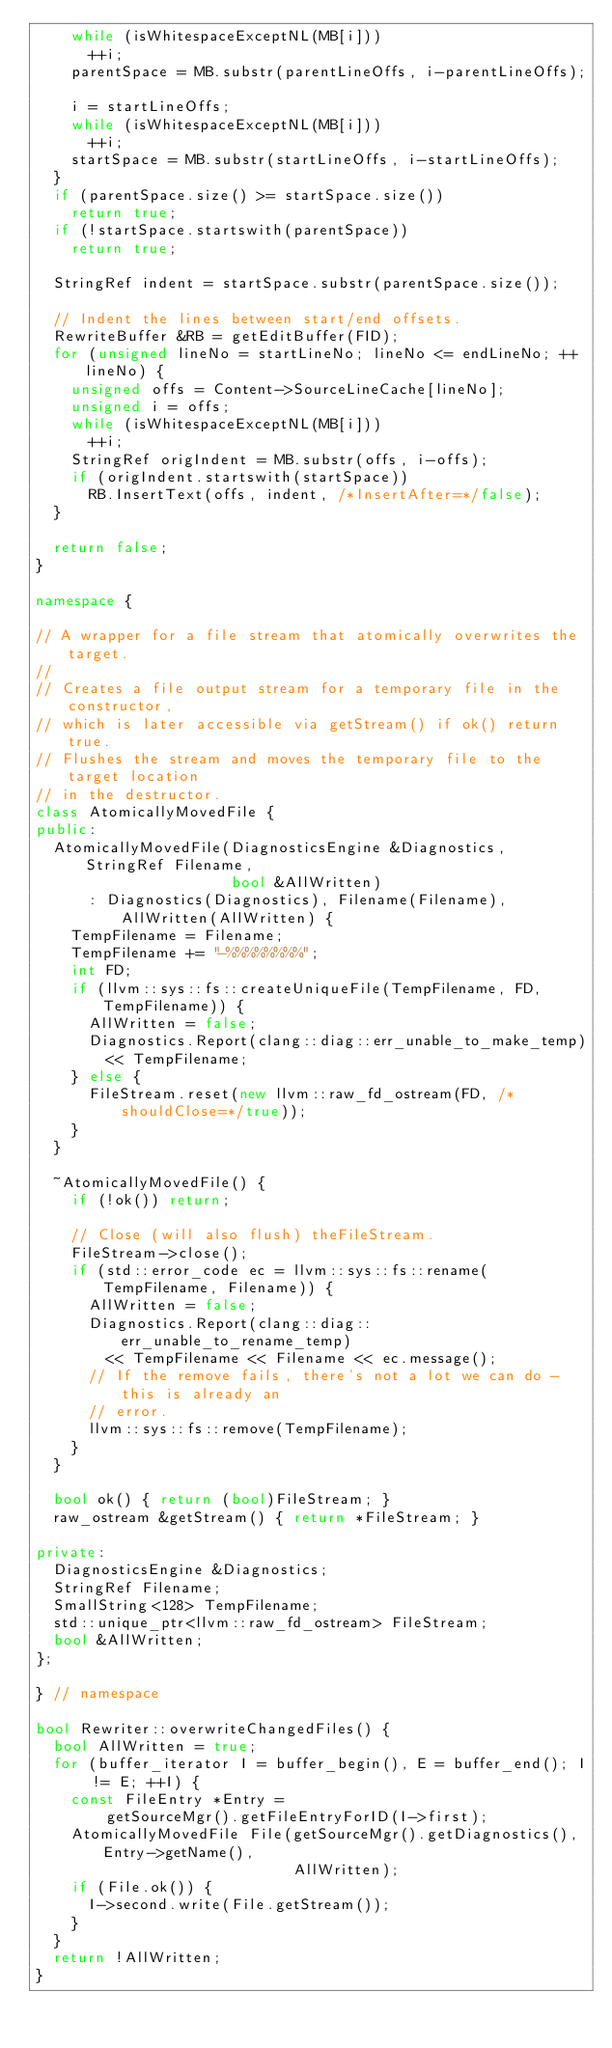Convert code to text. <code><loc_0><loc_0><loc_500><loc_500><_C++_>    while (isWhitespaceExceptNL(MB[i]))
      ++i;
    parentSpace = MB.substr(parentLineOffs, i-parentLineOffs);

    i = startLineOffs;
    while (isWhitespaceExceptNL(MB[i]))
      ++i;
    startSpace = MB.substr(startLineOffs, i-startLineOffs);
  }
  if (parentSpace.size() >= startSpace.size())
    return true;
  if (!startSpace.startswith(parentSpace))
    return true;

  StringRef indent = startSpace.substr(parentSpace.size());

  // Indent the lines between start/end offsets.
  RewriteBuffer &RB = getEditBuffer(FID);
  for (unsigned lineNo = startLineNo; lineNo <= endLineNo; ++lineNo) {
    unsigned offs = Content->SourceLineCache[lineNo];
    unsigned i = offs;
    while (isWhitespaceExceptNL(MB[i]))
      ++i;
    StringRef origIndent = MB.substr(offs, i-offs);
    if (origIndent.startswith(startSpace))
      RB.InsertText(offs, indent, /*InsertAfter=*/false);
  }

  return false;
}

namespace {

// A wrapper for a file stream that atomically overwrites the target.
//
// Creates a file output stream for a temporary file in the constructor,
// which is later accessible via getStream() if ok() return true.
// Flushes the stream and moves the temporary file to the target location
// in the destructor.
class AtomicallyMovedFile {
public:
  AtomicallyMovedFile(DiagnosticsEngine &Diagnostics, StringRef Filename,
                      bool &AllWritten)
      : Diagnostics(Diagnostics), Filename(Filename), AllWritten(AllWritten) {
    TempFilename = Filename;
    TempFilename += "-%%%%%%%%";
    int FD;
    if (llvm::sys::fs::createUniqueFile(TempFilename, FD, TempFilename)) {
      AllWritten = false;
      Diagnostics.Report(clang::diag::err_unable_to_make_temp)
        << TempFilename;
    } else {
      FileStream.reset(new llvm::raw_fd_ostream(FD, /*shouldClose=*/true));
    }
  }

  ~AtomicallyMovedFile() {
    if (!ok()) return;

    // Close (will also flush) theFileStream.
    FileStream->close();
    if (std::error_code ec = llvm::sys::fs::rename(TempFilename, Filename)) {
      AllWritten = false;
      Diagnostics.Report(clang::diag::err_unable_to_rename_temp)
        << TempFilename << Filename << ec.message();
      // If the remove fails, there's not a lot we can do - this is already an
      // error.
      llvm::sys::fs::remove(TempFilename);
    }
  }

  bool ok() { return (bool)FileStream; }
  raw_ostream &getStream() { return *FileStream; }

private:
  DiagnosticsEngine &Diagnostics;
  StringRef Filename;
  SmallString<128> TempFilename;
  std::unique_ptr<llvm::raw_fd_ostream> FileStream;
  bool &AllWritten;
};

} // namespace

bool Rewriter::overwriteChangedFiles() {
  bool AllWritten = true;
  for (buffer_iterator I = buffer_begin(), E = buffer_end(); I != E; ++I) {
    const FileEntry *Entry =
        getSourceMgr().getFileEntryForID(I->first);
    AtomicallyMovedFile File(getSourceMgr().getDiagnostics(), Entry->getName(),
                             AllWritten);
    if (File.ok()) {
      I->second.write(File.getStream());
    }
  }
  return !AllWritten;
}
</code> 